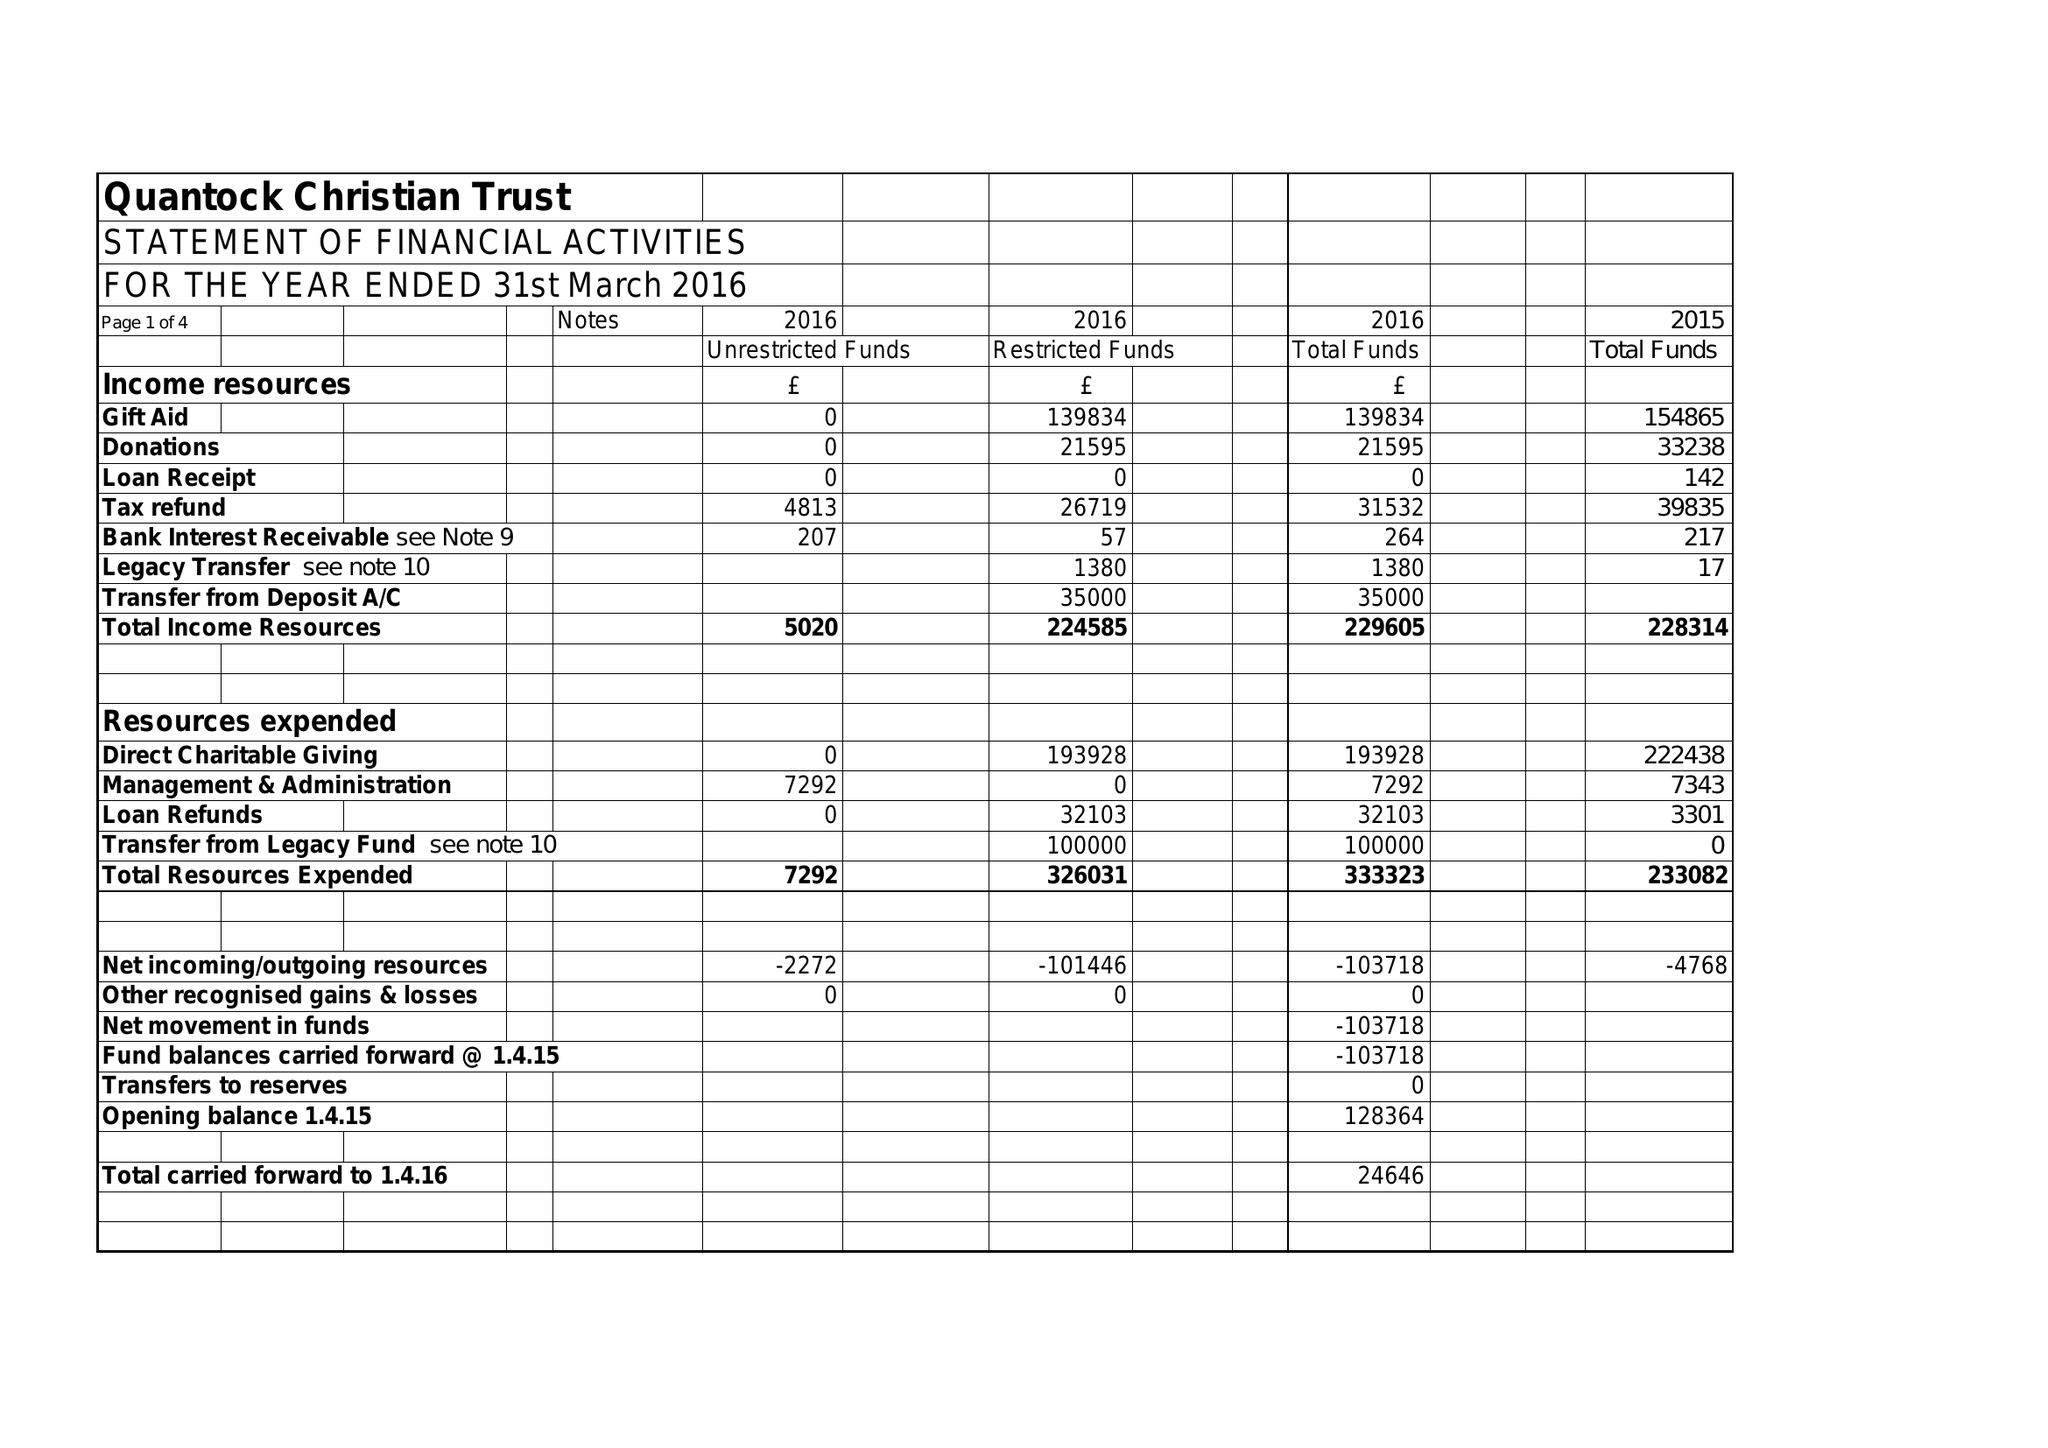What is the value for the charity_name?
Answer the question using a single word or phrase. Quantock Christian Trust 